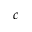Convert formula to latex. <formula><loc_0><loc_0><loc_500><loc_500>c</formula> 